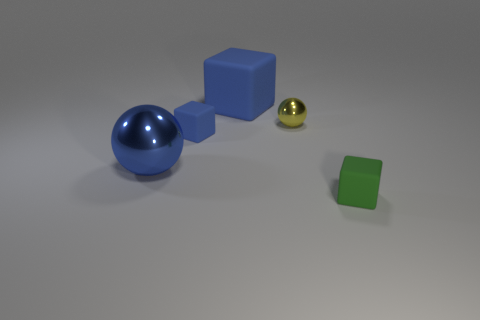There is a large blue object that is in front of the small shiny object; is it the same shape as the tiny blue object?
Offer a terse response. No. There is a small thing that is in front of the large metal ball; what is it made of?
Ensure brevity in your answer.  Rubber. How many tiny shiny things are the same shape as the large metal thing?
Your response must be concise. 1. There is a blue cube that is to the right of the matte object that is on the left side of the big rubber object; what is it made of?
Offer a very short reply. Rubber. There is a tiny matte object that is the same color as the large shiny object; what is its shape?
Offer a very short reply. Cube. Are there any tiny cyan things made of the same material as the tiny yellow object?
Offer a terse response. No. There is a tiny yellow thing; what shape is it?
Provide a short and direct response. Sphere. What number of big yellow rubber objects are there?
Give a very brief answer. 0. What color is the sphere on the right side of the tiny matte thing behind the big metal object?
Keep it short and to the point. Yellow. What color is the rubber block that is the same size as the green thing?
Give a very brief answer. Blue. 